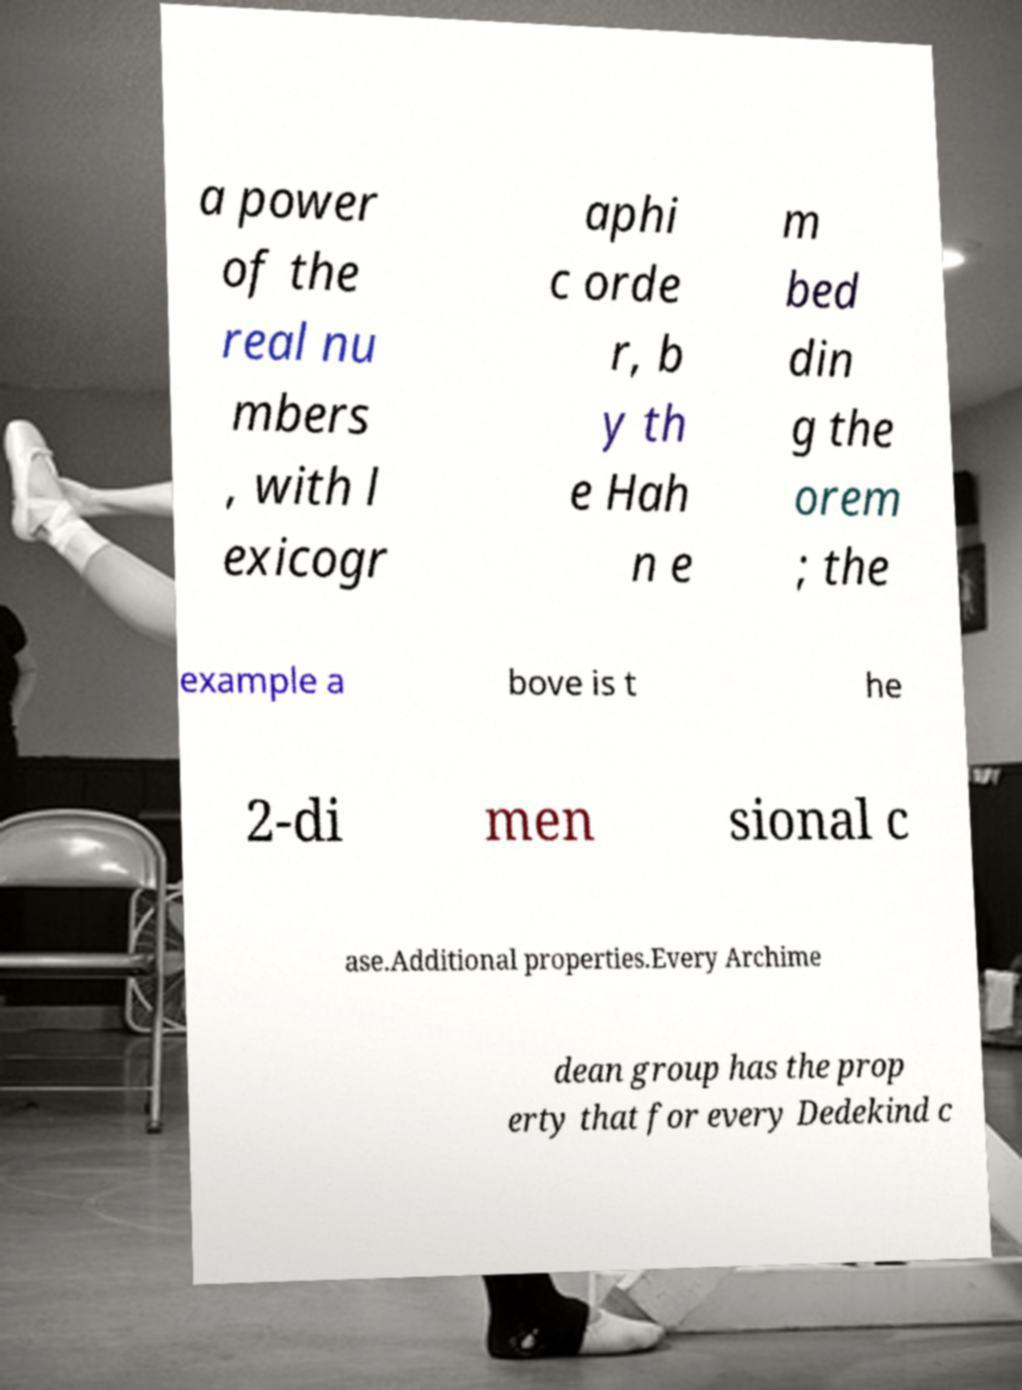Could you assist in decoding the text presented in this image and type it out clearly? a power of the real nu mbers , with l exicogr aphi c orde r, b y th e Hah n e m bed din g the orem ; the example a bove is t he 2-di men sional c ase.Additional properties.Every Archime dean group has the prop erty that for every Dedekind c 